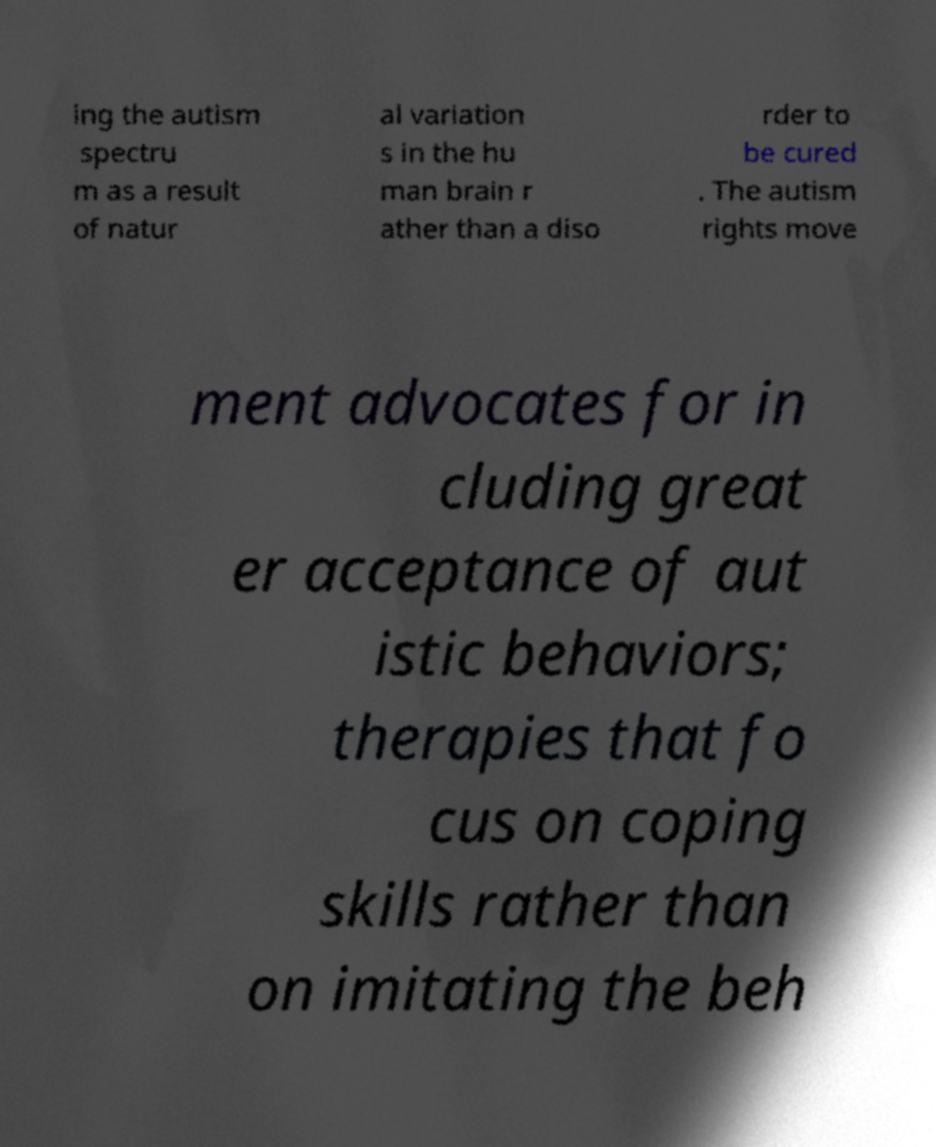What messages or text are displayed in this image? I need them in a readable, typed format. ing the autism spectru m as a result of natur al variation s in the hu man brain r ather than a diso rder to be cured . The autism rights move ment advocates for in cluding great er acceptance of aut istic behaviors; therapies that fo cus on coping skills rather than on imitating the beh 